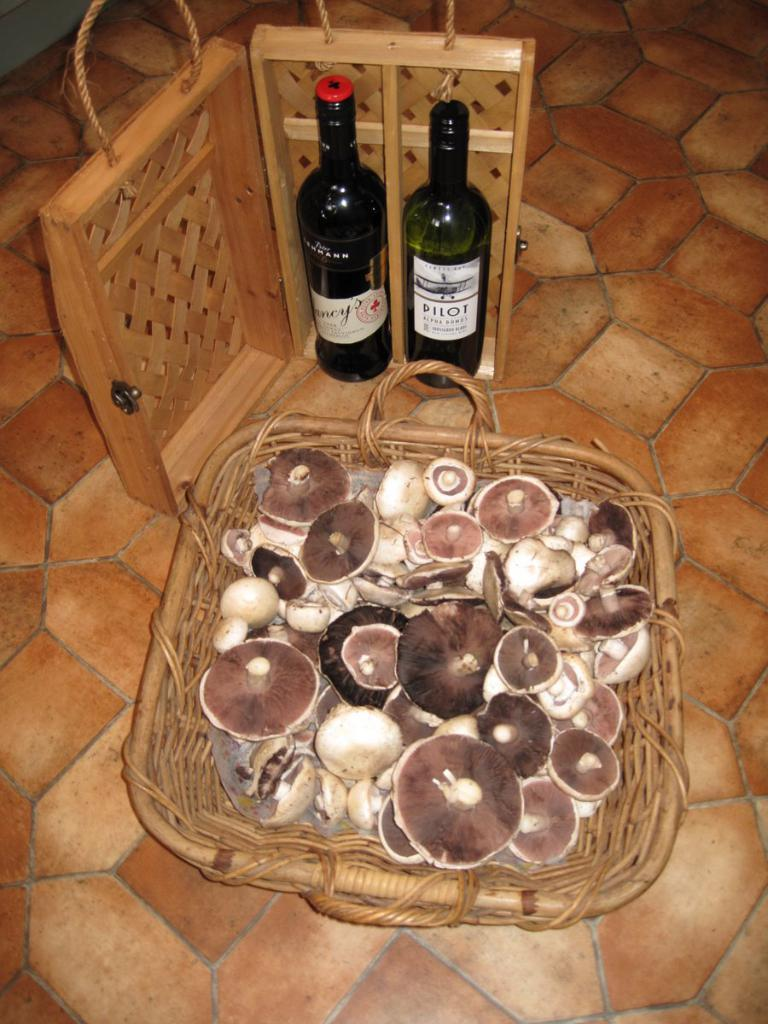<image>
Create a compact narrative representing the image presented. A basket full of mushrooms and two bottles of wine, one of which says Pilot. 